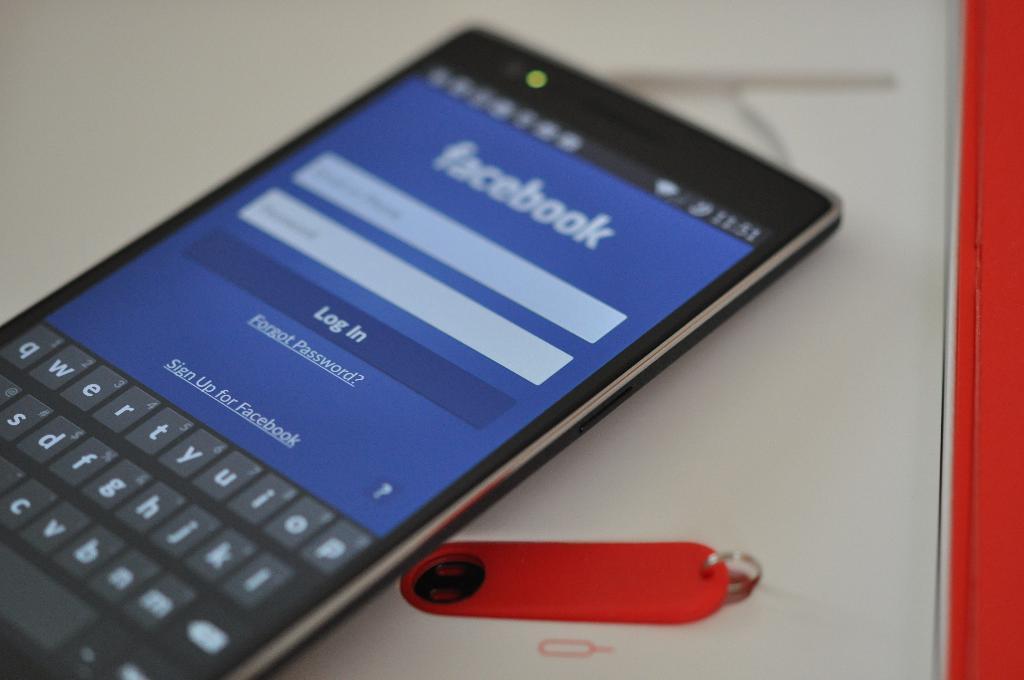What social media platform in showing up on the phone?
Offer a terse response. Facebook. What time is shown on the phone?
Offer a very short reply. 11:51. 